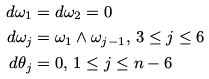<formula> <loc_0><loc_0><loc_500><loc_500>d \omega _ { 1 } & = d \omega _ { 2 } = 0 \\ d \omega _ { j } & = \omega _ { 1 } \wedge \omega _ { j - 1 } , \, 3 \leq j \leq 6 \\ d \theta _ { j } & = 0 , \, 1 \leq j \leq n - 6</formula> 